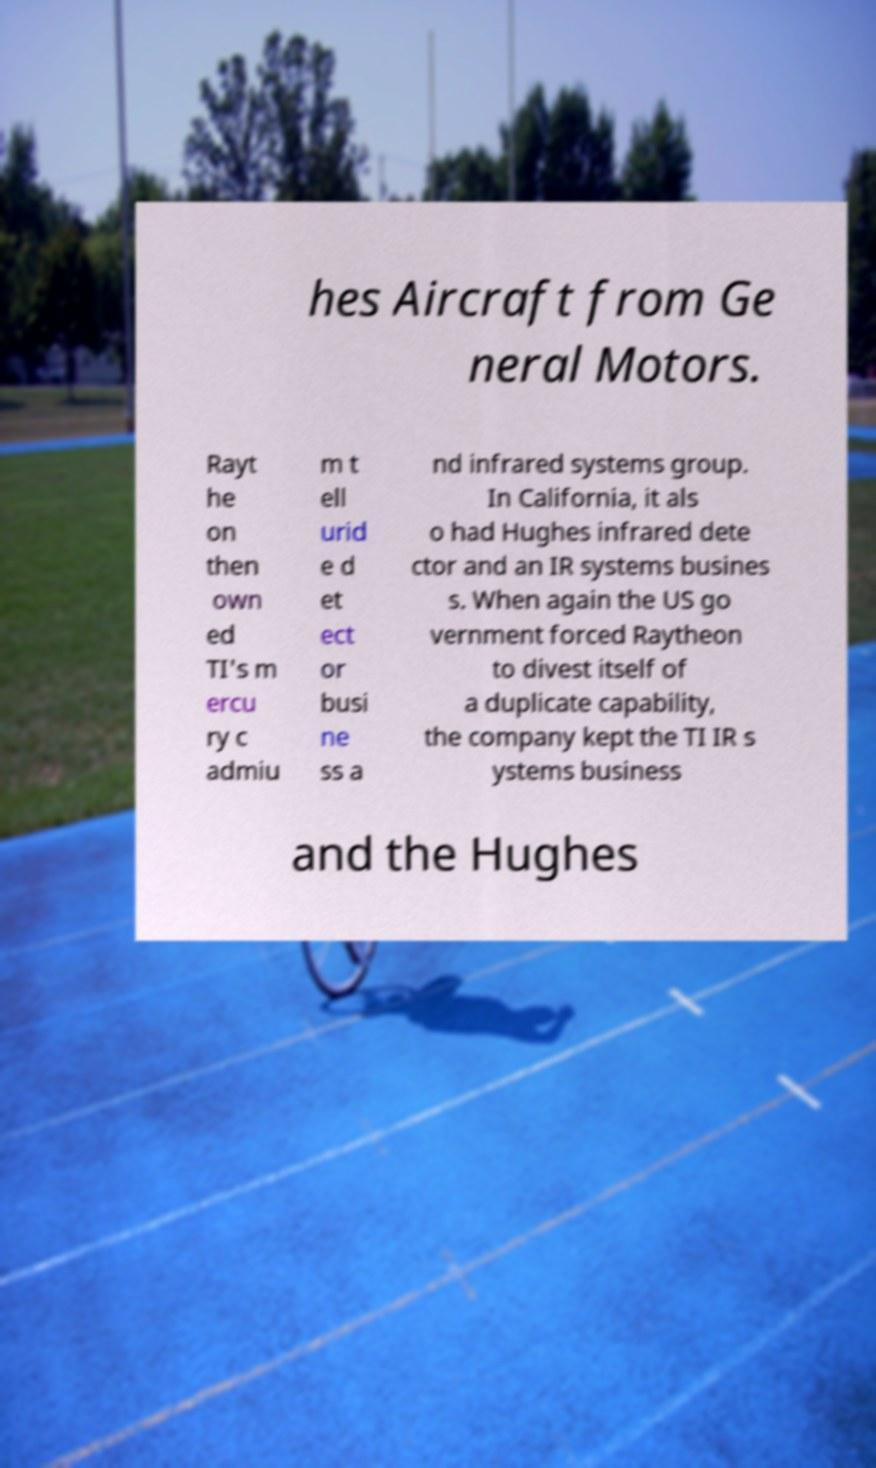Could you extract and type out the text from this image? hes Aircraft from Ge neral Motors. Rayt he on then own ed TI's m ercu ry c admiu m t ell urid e d et ect or busi ne ss a nd infrared systems group. In California, it als o had Hughes infrared dete ctor and an IR systems busines s. When again the US go vernment forced Raytheon to divest itself of a duplicate capability, the company kept the TI IR s ystems business and the Hughes 